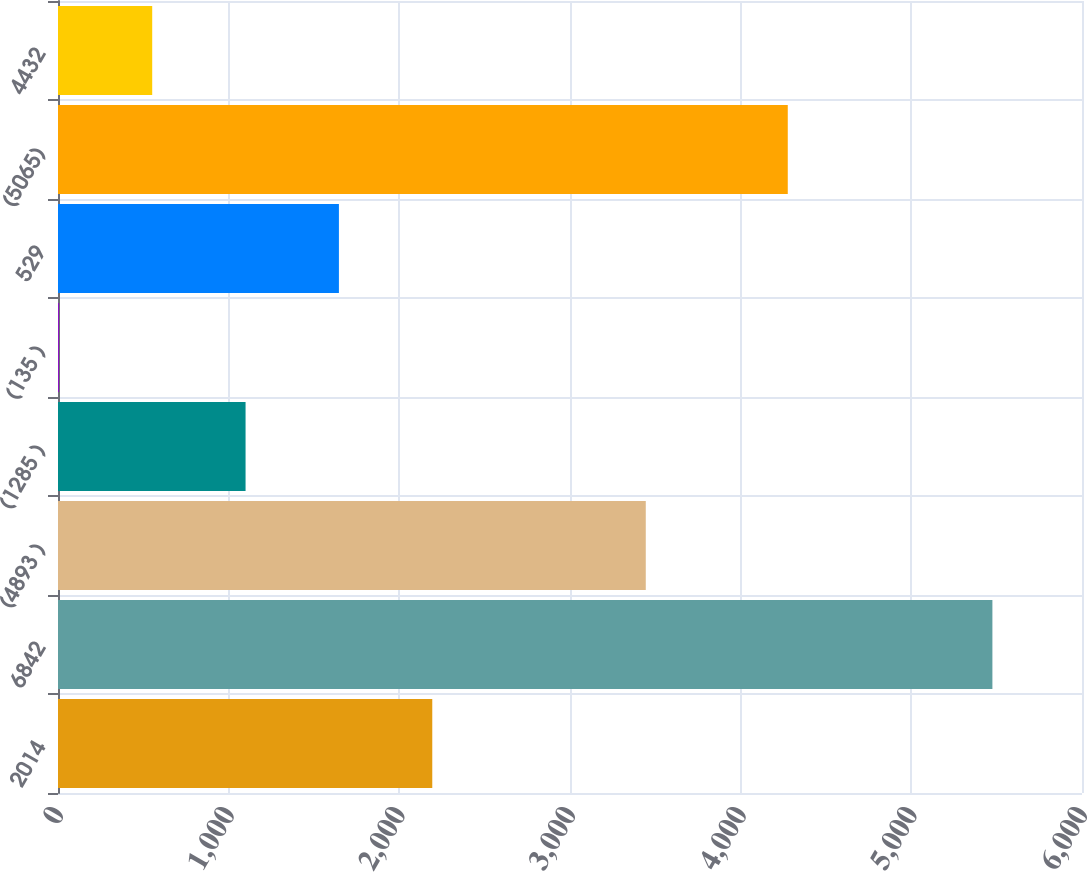Convert chart to OTSL. <chart><loc_0><loc_0><loc_500><loc_500><bar_chart><fcel>2014<fcel>6842<fcel>(4893 )<fcel>(1285 )<fcel>(135 )<fcel>529<fcel>(5065)<fcel>4432<nl><fcel>2193<fcel>5475<fcel>3444<fcel>1099<fcel>5<fcel>1646<fcel>4276<fcel>552<nl></chart> 